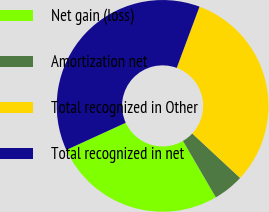Convert chart. <chart><loc_0><loc_0><loc_500><loc_500><pie_chart><fcel>Net gain (loss)<fcel>Amortization net<fcel>Total recognized in Other<fcel>Total recognized in net<nl><fcel>26.56%<fcel>4.69%<fcel>31.25%<fcel>37.5%<nl></chart> 